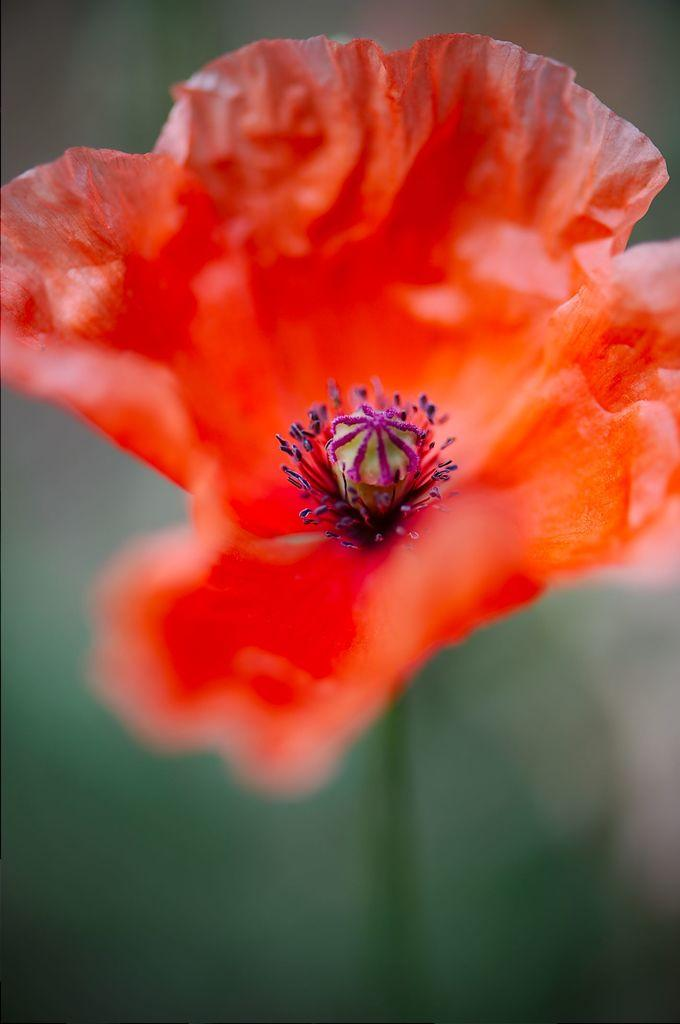What is the main subject of the image? There is a flower in the image. What color is the flower? The flower is orange in color. What type of plants can be seen rubbing against the bedroom wall in the image? There is no mention of plants, rubbing, or a bedroom wall in the image; it only features a single orange flower. 